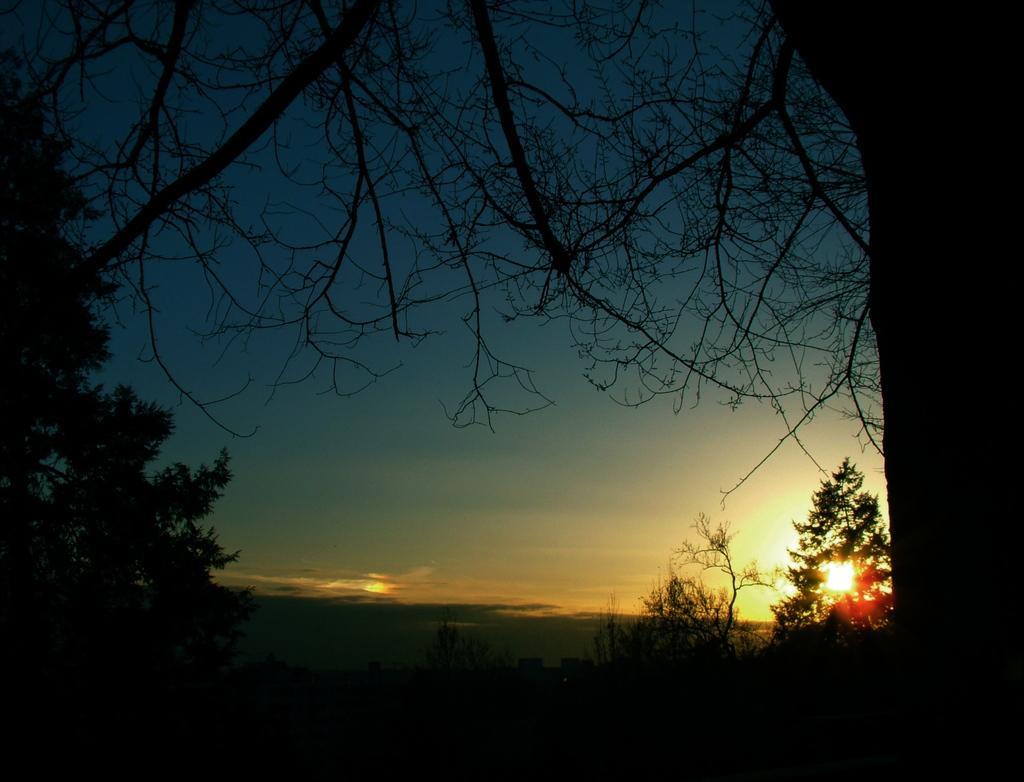Could you give a brief overview of what you see in this image? In this image we can see sky, trees, buildings and sun. 